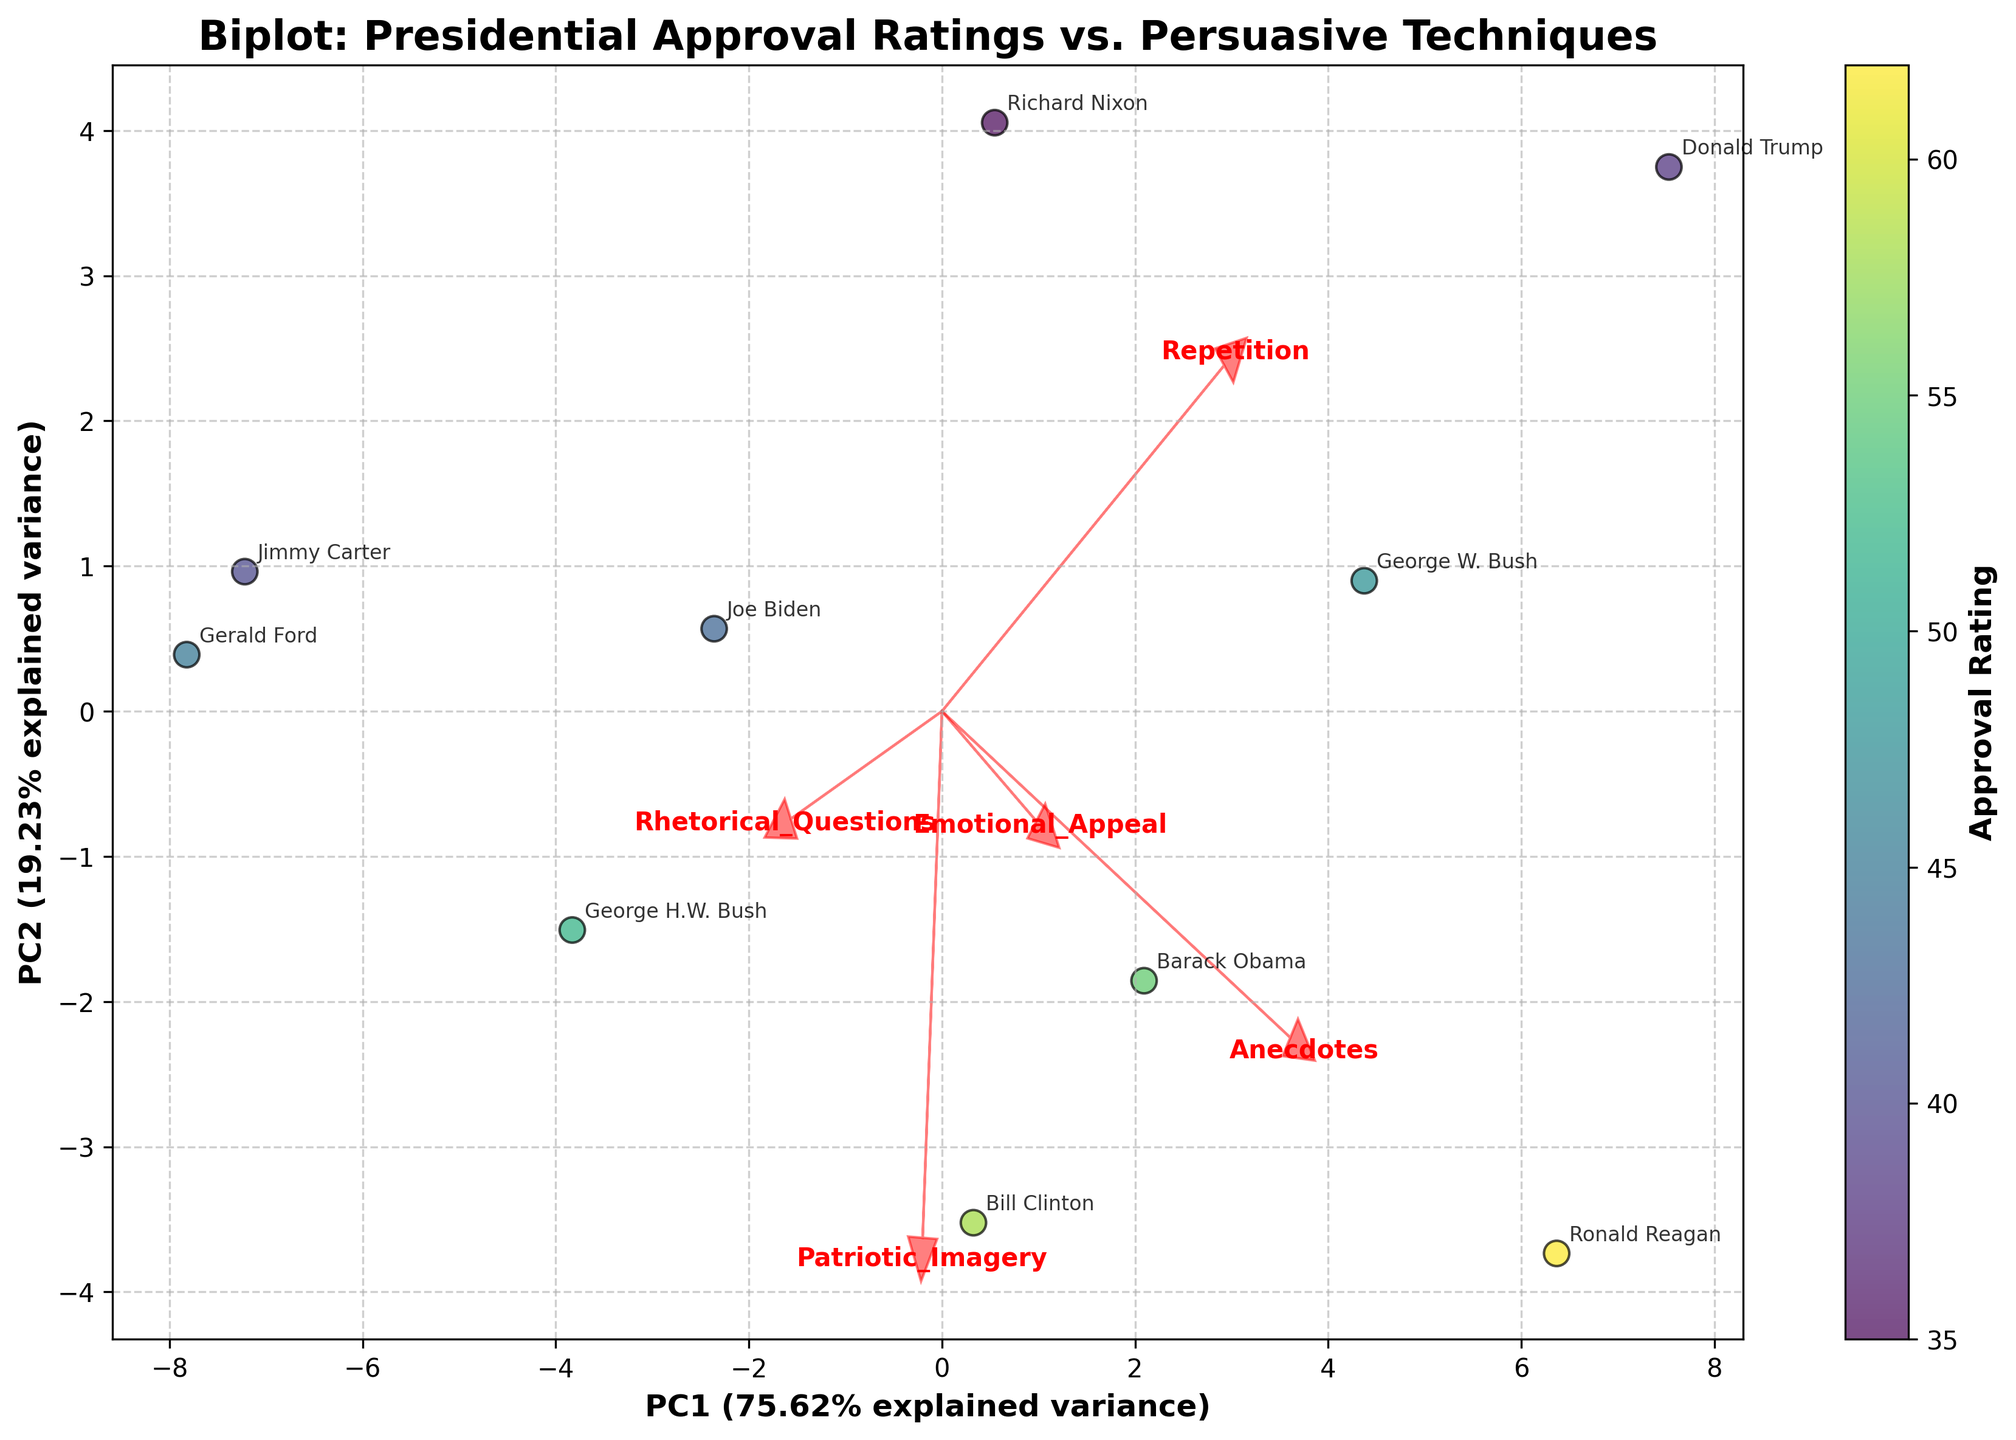What's the title of the figure? The title is written at the top of the figure and it indicates what the plot is about.
Answer: Biplot: Presidential Approval Ratings vs. Persuasive Techniques How many persuasive techniques are represented in the biplot? Each persuasive technique is represented by a feature vector, identified with an arrow and labeled with its name. Count these arrows to find the number of persuasive techniques.
Answer: 5 Which president has the lowest approval rating? The colorbar on the right side of the plot indicates the approval rating by color. Find the point with the darkest color, and then look at the president's name annotated near this point.
Answer: Richard Nixon What percentage of the total variance is explained by the first principal component (PC1)? The x-axis label shows the percentage of explained variance for PC1.
Answer: (exact percentage as shown on plot) Which persuasive technique vector points most strongly in the direction of President Clinton's data point? Look at the vectors near President Clinton's data point. The one with the longest arrow pointing towards his marker is strongest.
Answer: (specific technique) How do 'Repetition' and 'Rhetorical Questions' differ in their direction on the biplot? Compare the directions of the arrows labeled 'Repetition' and 'Rhetorical Questions'.
Answer: Different directions (exact details from plot) Which president has the highest utilization of 'Emotional Appeal'? The length and direction of the 'Emotional Appeal' vector indicate its influence. Find the president near the end of this vector.
Answer: Ronald Reagan Between 'Anecdotes' and 'Patriotic Imagery', which technique is more aligned with the second principal component (PC2)? Look at the alignment of the vectors respective to the y-axis, representing PC2.
Answer: Patriotic Imagery What relationships can be observed between the utilization of 'Repetition' and approval ratings among the presidents? Examine the correlation between the data points' positions relative to the 'Repetition' vector and the colors representing their approval ratings.
Answer: Generally positive correlation Which president’s utilization of persuasive techniques is most aligned with the first principal component (PC1)? Look at the projection of the presidents' data points on the x-axis, which represents PC1. The president closest to the extremes has the strongest alignment.
Answer: (specific president) 